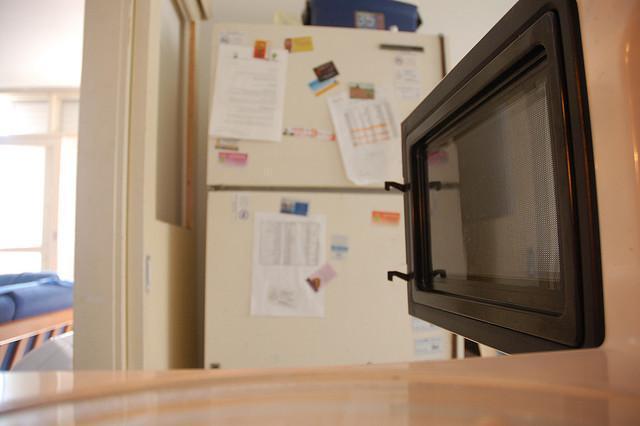How many refrigerators are visible?
Give a very brief answer. 1. 